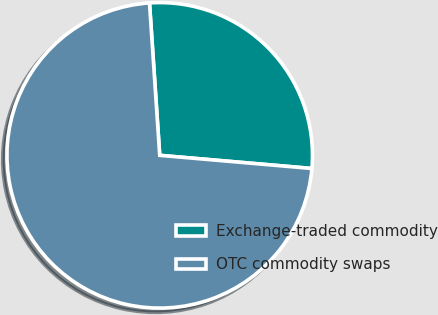Convert chart. <chart><loc_0><loc_0><loc_500><loc_500><pie_chart><fcel>Exchange-traded commodity<fcel>OTC commodity swaps<nl><fcel>27.44%<fcel>72.56%<nl></chart> 